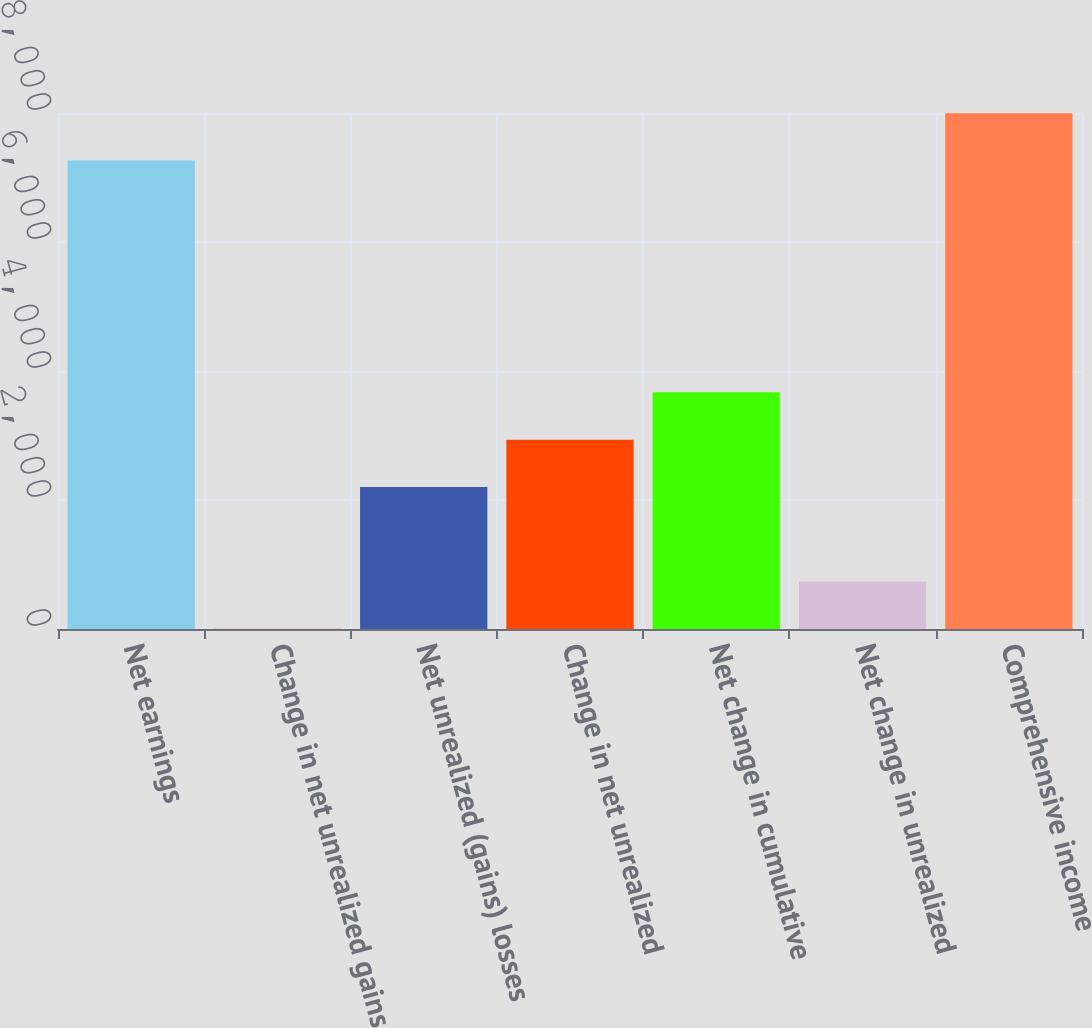<chart> <loc_0><loc_0><loc_500><loc_500><bar_chart><fcel>Net earnings<fcel>Change in net unrealized gains<fcel>Net unrealized (gains) losses<fcel>Change in net unrealized<fcel>Net change in cumulative<fcel>Net change in unrealized<fcel>Comprehensive income<nl><fcel>7264<fcel>2<fcel>2202.5<fcel>2936<fcel>3669.5<fcel>735.5<fcel>7997.5<nl></chart> 